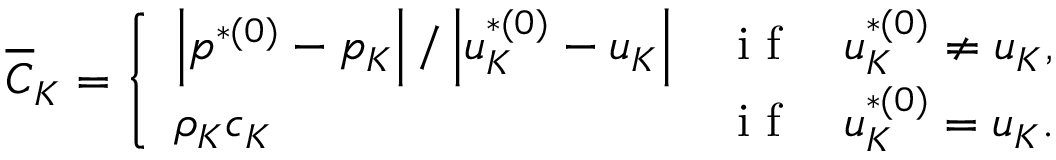<formula> <loc_0><loc_0><loc_500><loc_500>\overline { C } _ { K } = \left \{ \begin{array} { l l } { \left | p ^ { * ( 0 ) } - p _ { K } \right | / \left | u _ { K } ^ { * ( 0 ) } - u _ { K } \right | } & { i f \quad u _ { K } ^ { * ( 0 ) } \neq u _ { K } , } \\ { \rho _ { K } c _ { K } } & { i f \quad u _ { K } ^ { * ( 0 ) } = u _ { K } . } \end{array}</formula> 